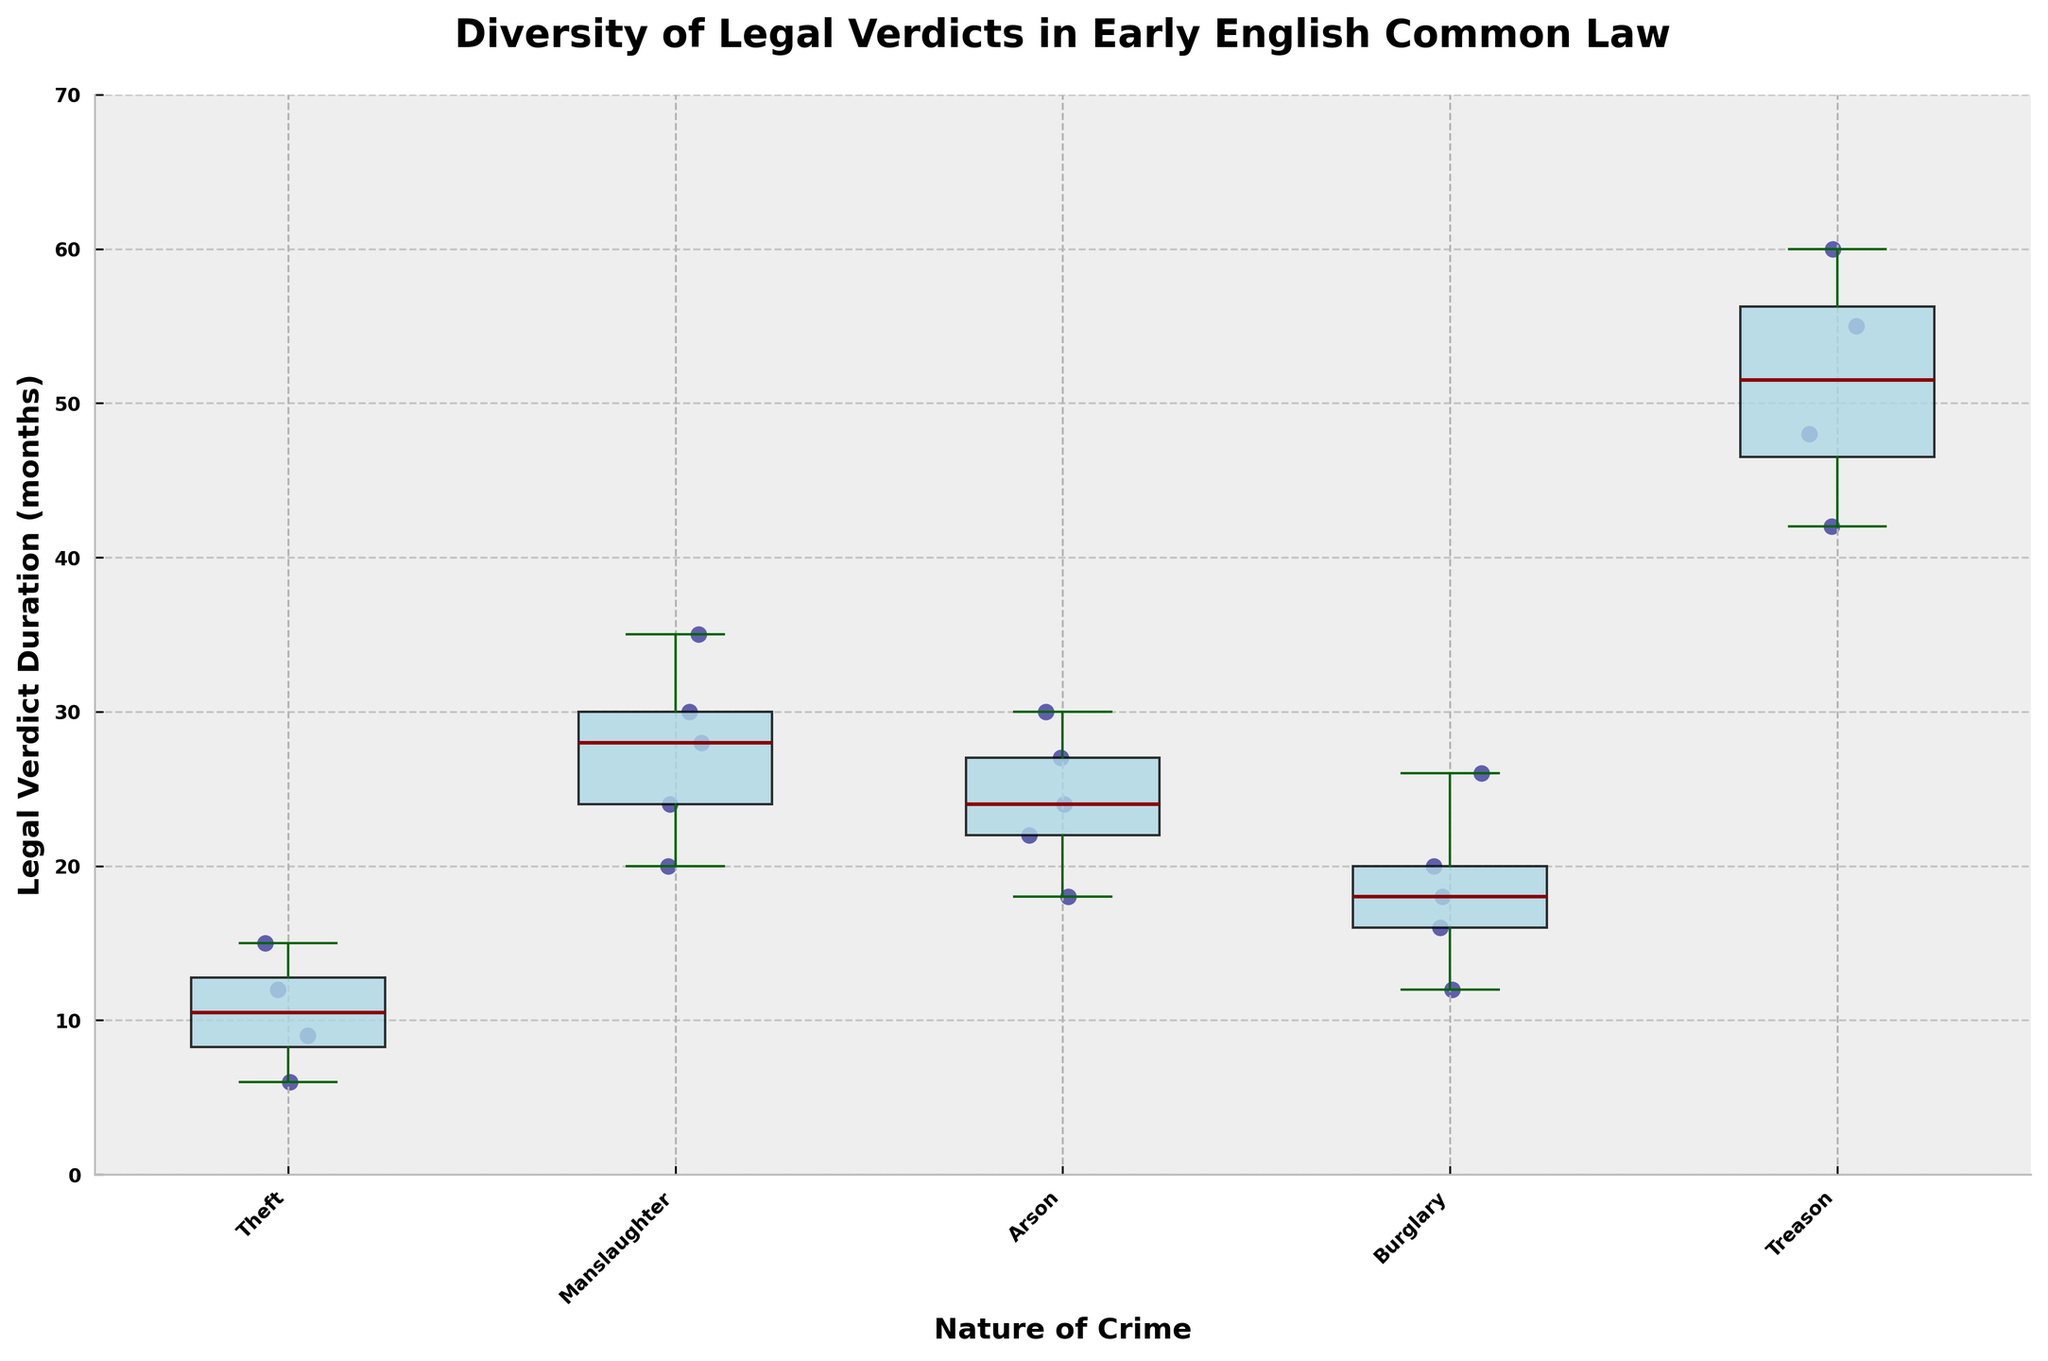What is the title of the chart? The title is usually found at the top of the chart and helps summarize the main topic of the data presented. This chart's title is prominently displayed.
Answer: Diversity of Legal Verdicts in Early English Common Law What is the median duration for manslaughter verdicts? The median value in a box plot is indicated by the line inside the box. For the 'Manslaughter' box plot, the red line represents the median.
Answer: 28 months Which crime category has the lowest legal verdict duration? Look for the box plot with the lowest whisker or scatter points below. Theft has the lowest overall points.
Answer: Theft Which nature of the crime has the highest variance in legal verdict duration? Variance can be inferred by the spread of the box plot and the distance between the whiskers. The more spread-out the box plot, the higher the variance. Treason shows the widest range.
Answer: Treason How many individual data points are there for arson cases? Count the number of scatter points above the 'Arson' category on the x-axis.
Answer: 5 What is the range of legal verdict durations for burglary? The range is the difference between the maximum and minimum values represented by the whiskers of the box plot for burglary.
Answer: 26 - 12 = 14 What is the minimum legal verdict duration across all crime categories? Identify the lowest scatter point on the entire plot. The lowest point represents the minimum duration, falling under Theft.
Answer: 6 months How does the mean value for treason verdicts compare to the median value? The median value is indicated by the red line in the treason box plot, and the mean would need to be inferred from the scatter points if not provided directly. The median appears around 53 months, and the scatter points averaging above it would indicate the mean is slightly higher.
Answer: Slightly higher Which crimes show outliers in their legal verdict durations? Outliers in a box plot appear as individual points separate from the main box and whiskers.
Answer: None What is the interquartile range (IQR) for arson verdicts? The IQR is calculated by subtracting the first quartile (bottom of the box) from the third quartile (top of the box) of the arson box plot.
Answer: Approximately 30 - 22 = 8 months 